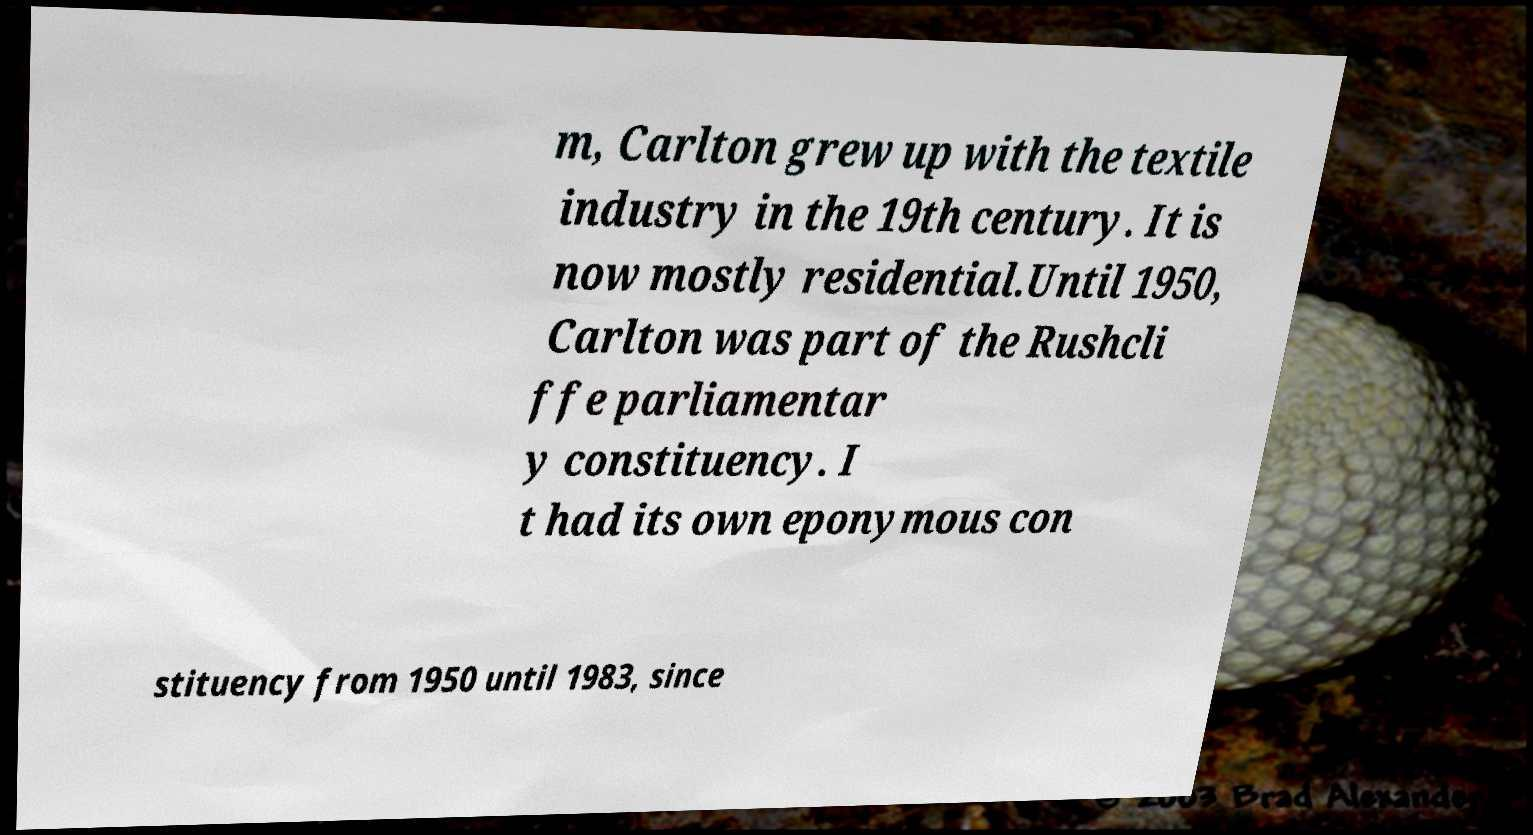For documentation purposes, I need the text within this image transcribed. Could you provide that? m, Carlton grew up with the textile industry in the 19th century. It is now mostly residential.Until 1950, Carlton was part of the Rushcli ffe parliamentar y constituency. I t had its own eponymous con stituency from 1950 until 1983, since 